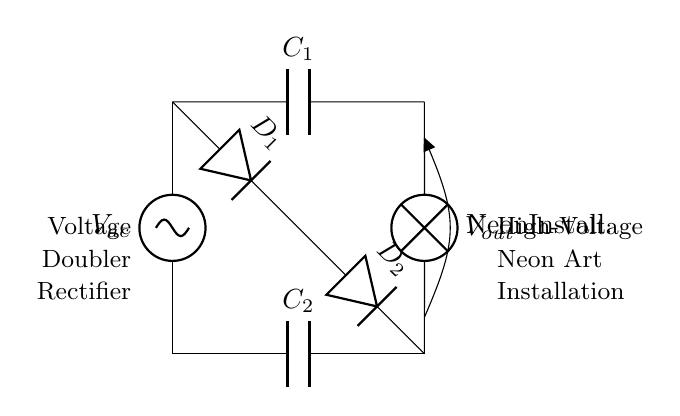What type of circuit is this? This is a voltage doubler rectifier circuit. The presence of capacitors and diodes used to double voltage indicates it's specifically designed for this purpose.
Answer: voltage doubler rectifier What is the load connected to this circuit? The load is a neon art installation, as indicated by the label next to the lamp symbol in the circuit diagram.
Answer: Neon Installation How many capacitors are in the circuit? There are two capacitors present in the circuit, labeled as C1 and C2. Counting directly from the diagram confirms this.
Answer: 2 What is the function of the diodes in this circuit? The diodes are used for rectification, converting alternating current to direct current. The arrangement allows for voltage doubling in conjunction with the capacitors.
Answer: Rectification What is the output voltage denoted as in this circuit? The output voltage is denoted as Vout, which is specifically noted near the output connections of the circuit diagram.
Answer: Vout Why is this circuit considered a voltage doubler? It is considered a voltage doubler because it uses a specific arrangement of diodes and capacitors that effectively doubles the input voltage for the output. This behavior can be inferred from the connections and components used.
Answer: Voltage doubler What role does C1 play in the circuit? C1 serves to store charge and contribute to the voltage doubling effect by accumulating energy when the AC signal is applied. Its position in the circuit indicates it is charged during one phase of the AC cycle.
Answer: Energy storage 